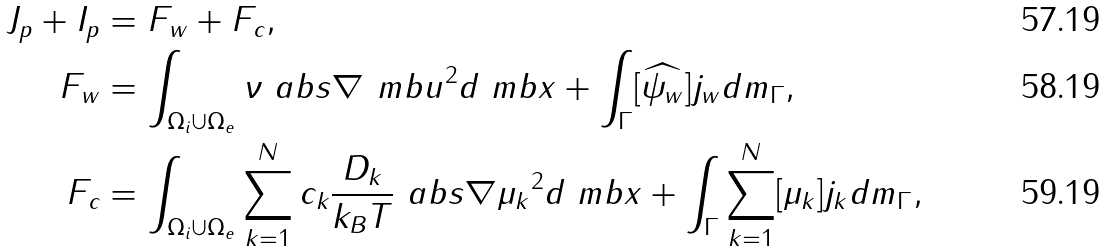Convert formula to latex. <formula><loc_0><loc_0><loc_500><loc_500>J _ { p } + I _ { p } & = F _ { w } + F _ { c } , \\ F _ { w } & = \int _ { \Omega _ { i } \cup \Omega _ { e } } \nu \ a b s { \nabla \ m b { u } } ^ { 2 } d \ m b { x } + \int _ { \Gamma } [ \widehat { \psi _ { w } } ] j _ { w } d m _ { \Gamma } , \\ F _ { c } & = \int _ { \Omega _ { i } \cup \Omega _ { e } } \sum _ { k = 1 } ^ { N } c _ { k } \frac { D _ { k } } { k _ { B } T } \ a b s { \nabla \mu _ { k } } ^ { 2 } d \ m b { x } + \int _ { \Gamma } \sum _ { k = 1 } ^ { N } [ \mu _ { k } ] j _ { k } d m _ { \Gamma } ,</formula> 